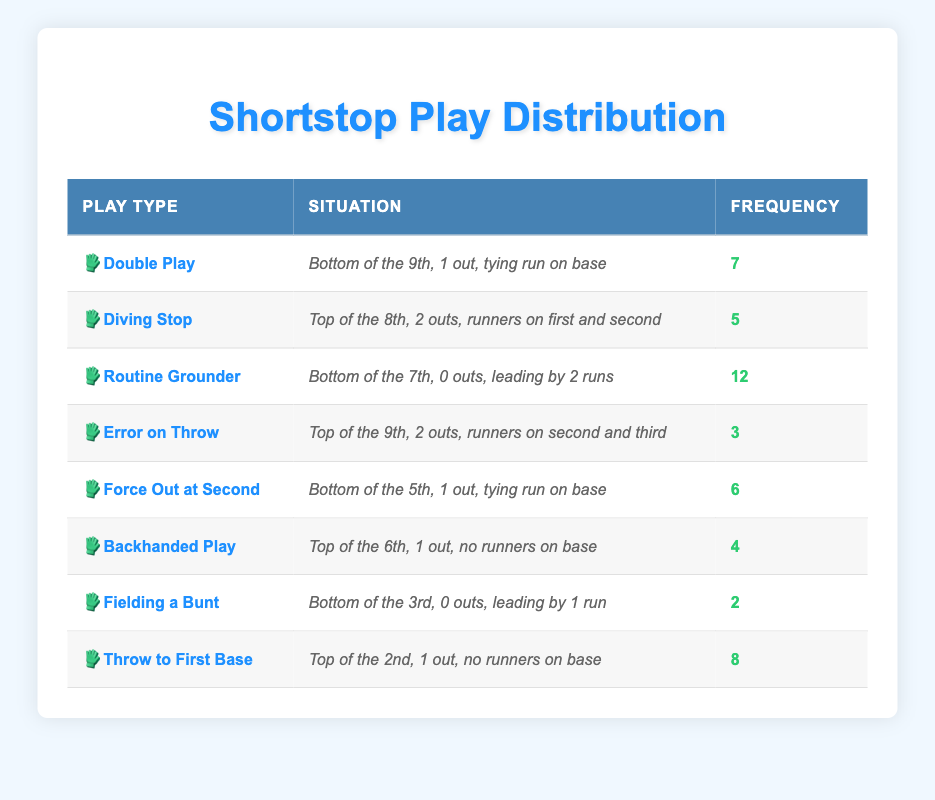What is the frequency of Routine Grounder plays? According to the table, the frequency of Routine Grounder plays is listed directly as 12.
Answer: 12 How many plays were made by shortstops in the Bottom of the 9th? Two specific plays are made in the Bottom of the 9th: Double Play (7 times) and Force Out at Second (6 times). Adding these frequencies gives 7 + 6 = 13.
Answer: 13 Is there a play type that occurred less frequently than Fielding a Bunt? The only play that occurred less frequently than Fielding a Bunt (2 times) is the Error on Throw (3 times) and all other plays occurred more frequently. Therefore, the answer is yes.
Answer: Yes What is the total frequency of all plays made at the Top of the 6th and above? The relevant plays are Diving Stop (5), Error on Throw (3), Backhanded Play (4), and Throw to First Base (8). Adding these frequencies gives 5 + 3 + 4 + 8 = 20.
Answer: 20 What play type has the highest frequency in crucial game situations? The play type with the highest frequency is Routine Grounder with a frequency of 12, which is higher than any other play in the table.
Answer: Routine Grounder In how many situations did shortstops make plays when there was a tying run on base? There are two situations with a tying run on base: Bottom of the 9th (Double Play) and Bottom of the 5th (Force Out at Second). Therefore, the count is 2.
Answer: 2 What is the average frequency of all plays listed in the table? To find the average, we first sum the frequencies: 7 + 5 + 12 + 3 + 6 + 4 + 2 + 8 = 47. There are 8 play types total. Thus, the average is 47 / 8 = 5.875.
Answer: 5.875 Which play type has the same frequency as the Force Out at Second? The Force Out at Second has a frequency of 6, and after checking the table, no other play type shares this frequency. Therefore, the answer is none.
Answer: None Is the number of Diving Stops greater than the sum of Fielding a Bunt and Error on Throw? The frequency for Diving Stops is 5, while Fielding a Bunt is 2 and Error on Throw is 3. The sum of Fielding a Bunt and Error on Throw is 2 + 3 = 5, which is not greater. Therefore, the answer is no.
Answer: No 